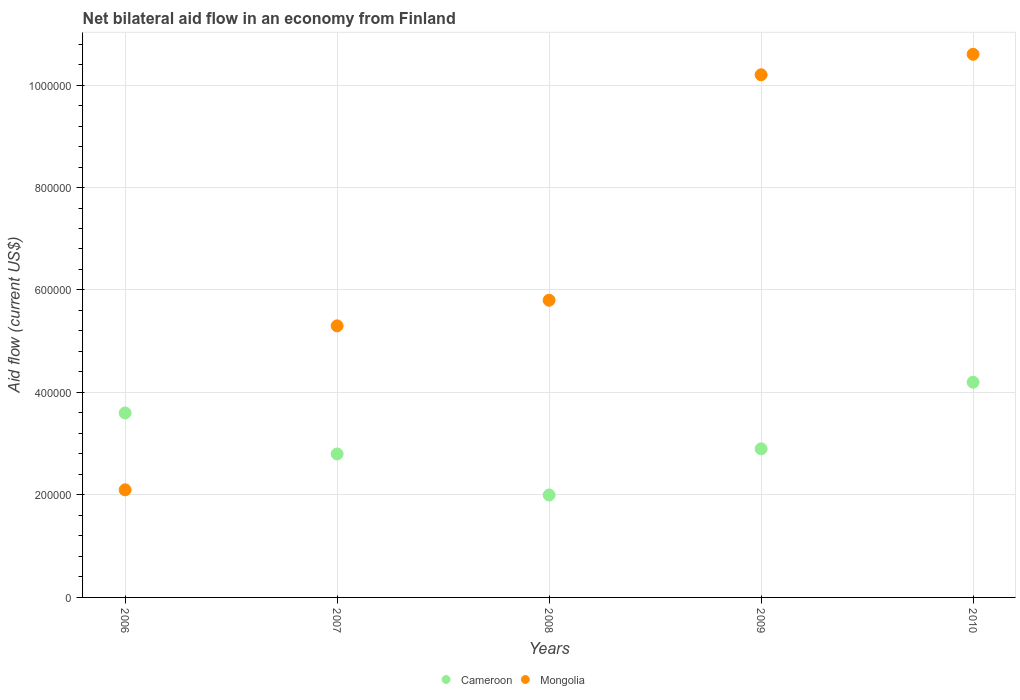Is the number of dotlines equal to the number of legend labels?
Offer a terse response. Yes. What is the net bilateral aid flow in Mongolia in 2008?
Offer a terse response. 5.80e+05. Across all years, what is the maximum net bilateral aid flow in Mongolia?
Your response must be concise. 1.06e+06. Across all years, what is the minimum net bilateral aid flow in Mongolia?
Your answer should be very brief. 2.10e+05. In which year was the net bilateral aid flow in Cameroon maximum?
Ensure brevity in your answer.  2010. In which year was the net bilateral aid flow in Cameroon minimum?
Your answer should be very brief. 2008. What is the total net bilateral aid flow in Mongolia in the graph?
Ensure brevity in your answer.  3.40e+06. What is the difference between the net bilateral aid flow in Mongolia in 2007 and that in 2008?
Your answer should be compact. -5.00e+04. In the year 2010, what is the difference between the net bilateral aid flow in Cameroon and net bilateral aid flow in Mongolia?
Offer a very short reply. -6.40e+05. In how many years, is the net bilateral aid flow in Mongolia greater than 760000 US$?
Your answer should be very brief. 2. What is the ratio of the net bilateral aid flow in Cameroon in 2006 to that in 2007?
Give a very brief answer. 1.29. Is the net bilateral aid flow in Cameroon in 2007 less than that in 2009?
Ensure brevity in your answer.  Yes. What is the difference between the highest and the lowest net bilateral aid flow in Mongolia?
Provide a succinct answer. 8.50e+05. In how many years, is the net bilateral aid flow in Cameroon greater than the average net bilateral aid flow in Cameroon taken over all years?
Offer a terse response. 2. Is the sum of the net bilateral aid flow in Cameroon in 2007 and 2008 greater than the maximum net bilateral aid flow in Mongolia across all years?
Your response must be concise. No. Is the net bilateral aid flow in Cameroon strictly less than the net bilateral aid flow in Mongolia over the years?
Your answer should be very brief. No. How many dotlines are there?
Keep it short and to the point. 2. Does the graph contain any zero values?
Provide a succinct answer. No. Does the graph contain grids?
Provide a short and direct response. Yes. How many legend labels are there?
Your answer should be very brief. 2. How are the legend labels stacked?
Your answer should be compact. Horizontal. What is the title of the graph?
Ensure brevity in your answer.  Net bilateral aid flow in an economy from Finland. What is the label or title of the Y-axis?
Your response must be concise. Aid flow (current US$). What is the Aid flow (current US$) in Cameroon in 2006?
Provide a short and direct response. 3.60e+05. What is the Aid flow (current US$) in Mongolia in 2007?
Provide a succinct answer. 5.30e+05. What is the Aid flow (current US$) of Mongolia in 2008?
Your answer should be compact. 5.80e+05. What is the Aid flow (current US$) of Mongolia in 2009?
Offer a very short reply. 1.02e+06. What is the Aid flow (current US$) of Cameroon in 2010?
Offer a terse response. 4.20e+05. What is the Aid flow (current US$) in Mongolia in 2010?
Your answer should be very brief. 1.06e+06. Across all years, what is the maximum Aid flow (current US$) of Cameroon?
Provide a succinct answer. 4.20e+05. Across all years, what is the maximum Aid flow (current US$) of Mongolia?
Provide a short and direct response. 1.06e+06. Across all years, what is the minimum Aid flow (current US$) of Cameroon?
Keep it short and to the point. 2.00e+05. Across all years, what is the minimum Aid flow (current US$) in Mongolia?
Give a very brief answer. 2.10e+05. What is the total Aid flow (current US$) in Cameroon in the graph?
Make the answer very short. 1.55e+06. What is the total Aid flow (current US$) of Mongolia in the graph?
Make the answer very short. 3.40e+06. What is the difference between the Aid flow (current US$) of Cameroon in 2006 and that in 2007?
Your answer should be very brief. 8.00e+04. What is the difference between the Aid flow (current US$) in Mongolia in 2006 and that in 2007?
Make the answer very short. -3.20e+05. What is the difference between the Aid flow (current US$) in Mongolia in 2006 and that in 2008?
Ensure brevity in your answer.  -3.70e+05. What is the difference between the Aid flow (current US$) of Mongolia in 2006 and that in 2009?
Your answer should be very brief. -8.10e+05. What is the difference between the Aid flow (current US$) in Cameroon in 2006 and that in 2010?
Your answer should be very brief. -6.00e+04. What is the difference between the Aid flow (current US$) of Mongolia in 2006 and that in 2010?
Your answer should be very brief. -8.50e+05. What is the difference between the Aid flow (current US$) in Cameroon in 2007 and that in 2008?
Offer a terse response. 8.00e+04. What is the difference between the Aid flow (current US$) of Cameroon in 2007 and that in 2009?
Offer a terse response. -10000. What is the difference between the Aid flow (current US$) in Mongolia in 2007 and that in 2009?
Offer a very short reply. -4.90e+05. What is the difference between the Aid flow (current US$) of Mongolia in 2007 and that in 2010?
Make the answer very short. -5.30e+05. What is the difference between the Aid flow (current US$) of Cameroon in 2008 and that in 2009?
Provide a short and direct response. -9.00e+04. What is the difference between the Aid flow (current US$) in Mongolia in 2008 and that in 2009?
Provide a short and direct response. -4.40e+05. What is the difference between the Aid flow (current US$) in Mongolia in 2008 and that in 2010?
Ensure brevity in your answer.  -4.80e+05. What is the difference between the Aid flow (current US$) of Cameroon in 2006 and the Aid flow (current US$) of Mongolia in 2009?
Your answer should be compact. -6.60e+05. What is the difference between the Aid flow (current US$) of Cameroon in 2006 and the Aid flow (current US$) of Mongolia in 2010?
Your answer should be compact. -7.00e+05. What is the difference between the Aid flow (current US$) in Cameroon in 2007 and the Aid flow (current US$) in Mongolia in 2008?
Provide a succinct answer. -3.00e+05. What is the difference between the Aid flow (current US$) in Cameroon in 2007 and the Aid flow (current US$) in Mongolia in 2009?
Provide a short and direct response. -7.40e+05. What is the difference between the Aid flow (current US$) in Cameroon in 2007 and the Aid flow (current US$) in Mongolia in 2010?
Keep it short and to the point. -7.80e+05. What is the difference between the Aid flow (current US$) in Cameroon in 2008 and the Aid flow (current US$) in Mongolia in 2009?
Make the answer very short. -8.20e+05. What is the difference between the Aid flow (current US$) of Cameroon in 2008 and the Aid flow (current US$) of Mongolia in 2010?
Keep it short and to the point. -8.60e+05. What is the difference between the Aid flow (current US$) in Cameroon in 2009 and the Aid flow (current US$) in Mongolia in 2010?
Your response must be concise. -7.70e+05. What is the average Aid flow (current US$) in Cameroon per year?
Your answer should be compact. 3.10e+05. What is the average Aid flow (current US$) of Mongolia per year?
Provide a short and direct response. 6.80e+05. In the year 2008, what is the difference between the Aid flow (current US$) in Cameroon and Aid flow (current US$) in Mongolia?
Provide a short and direct response. -3.80e+05. In the year 2009, what is the difference between the Aid flow (current US$) in Cameroon and Aid flow (current US$) in Mongolia?
Provide a short and direct response. -7.30e+05. In the year 2010, what is the difference between the Aid flow (current US$) of Cameroon and Aid flow (current US$) of Mongolia?
Offer a very short reply. -6.40e+05. What is the ratio of the Aid flow (current US$) in Cameroon in 2006 to that in 2007?
Keep it short and to the point. 1.29. What is the ratio of the Aid flow (current US$) of Mongolia in 2006 to that in 2007?
Provide a succinct answer. 0.4. What is the ratio of the Aid flow (current US$) of Mongolia in 2006 to that in 2008?
Your answer should be compact. 0.36. What is the ratio of the Aid flow (current US$) of Cameroon in 2006 to that in 2009?
Provide a succinct answer. 1.24. What is the ratio of the Aid flow (current US$) in Mongolia in 2006 to that in 2009?
Provide a succinct answer. 0.21. What is the ratio of the Aid flow (current US$) of Cameroon in 2006 to that in 2010?
Ensure brevity in your answer.  0.86. What is the ratio of the Aid flow (current US$) of Mongolia in 2006 to that in 2010?
Give a very brief answer. 0.2. What is the ratio of the Aid flow (current US$) of Mongolia in 2007 to that in 2008?
Make the answer very short. 0.91. What is the ratio of the Aid flow (current US$) in Cameroon in 2007 to that in 2009?
Keep it short and to the point. 0.97. What is the ratio of the Aid flow (current US$) in Mongolia in 2007 to that in 2009?
Provide a succinct answer. 0.52. What is the ratio of the Aid flow (current US$) in Mongolia in 2007 to that in 2010?
Provide a short and direct response. 0.5. What is the ratio of the Aid flow (current US$) in Cameroon in 2008 to that in 2009?
Make the answer very short. 0.69. What is the ratio of the Aid flow (current US$) in Mongolia in 2008 to that in 2009?
Your answer should be very brief. 0.57. What is the ratio of the Aid flow (current US$) of Cameroon in 2008 to that in 2010?
Make the answer very short. 0.48. What is the ratio of the Aid flow (current US$) of Mongolia in 2008 to that in 2010?
Your response must be concise. 0.55. What is the ratio of the Aid flow (current US$) of Cameroon in 2009 to that in 2010?
Your answer should be very brief. 0.69. What is the ratio of the Aid flow (current US$) of Mongolia in 2009 to that in 2010?
Keep it short and to the point. 0.96. What is the difference between the highest and the lowest Aid flow (current US$) in Cameroon?
Offer a very short reply. 2.20e+05. What is the difference between the highest and the lowest Aid flow (current US$) in Mongolia?
Offer a terse response. 8.50e+05. 